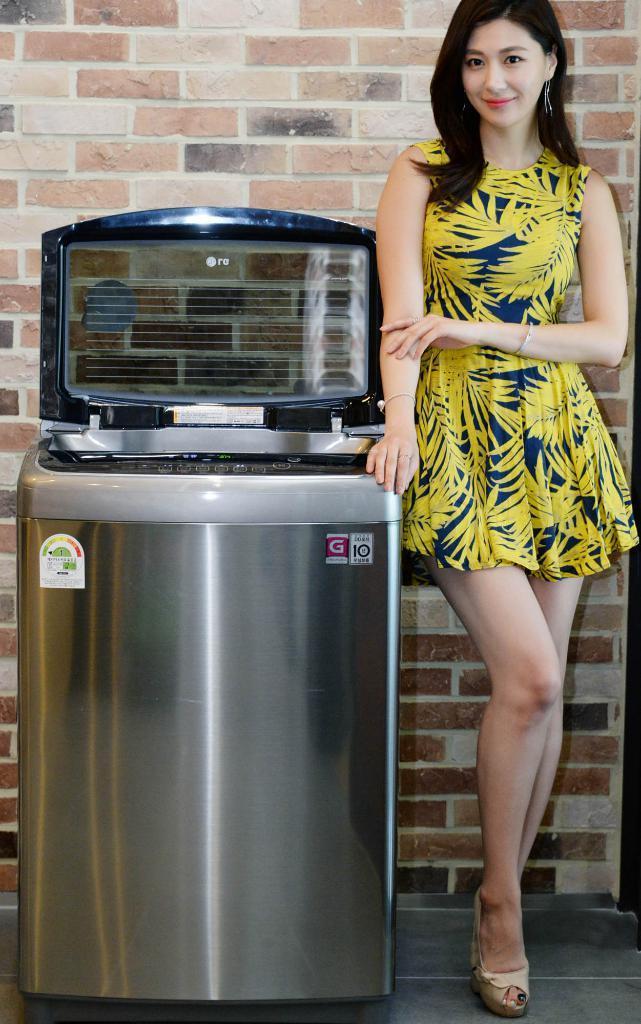In one or two sentences, can you explain what this image depicts? In this image we can see a washing machine. On the right there is a lady standing and smiling. In the background there is a wall. 